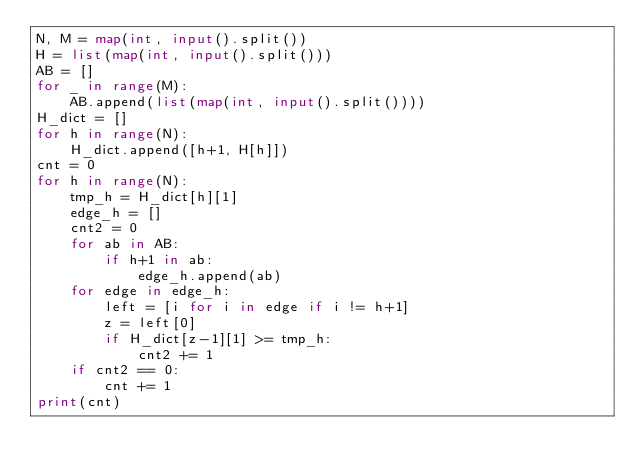Convert code to text. <code><loc_0><loc_0><loc_500><loc_500><_Python_>N, M = map(int, input().split())
H = list(map(int, input().split()))
AB = []
for _ in range(M):
    AB.append(list(map(int, input().split())))
H_dict = []
for h in range(N):
    H_dict.append([h+1, H[h]])
cnt = 0
for h in range(N):
    tmp_h = H_dict[h][1]
    edge_h = []
    cnt2 = 0
    for ab in AB:
        if h+1 in ab:
            edge_h.append(ab)
    for edge in edge_h:
        left = [i for i in edge if i != h+1]
        z = left[0]
        if H_dict[z-1][1] >= tmp_h:
            cnt2 += 1
    if cnt2 == 0:
        cnt += 1
print(cnt)</code> 